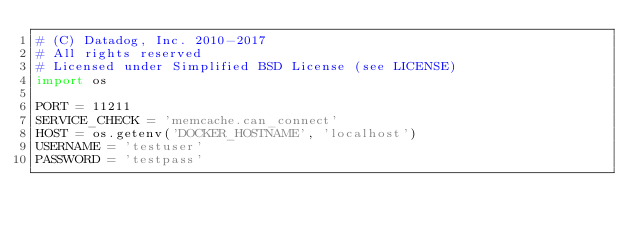Convert code to text. <code><loc_0><loc_0><loc_500><loc_500><_Python_># (C) Datadog, Inc. 2010-2017
# All rights reserved
# Licensed under Simplified BSD License (see LICENSE)
import os

PORT = 11211
SERVICE_CHECK = 'memcache.can_connect'
HOST = os.getenv('DOCKER_HOSTNAME', 'localhost')
USERNAME = 'testuser'
PASSWORD = 'testpass'
</code> 